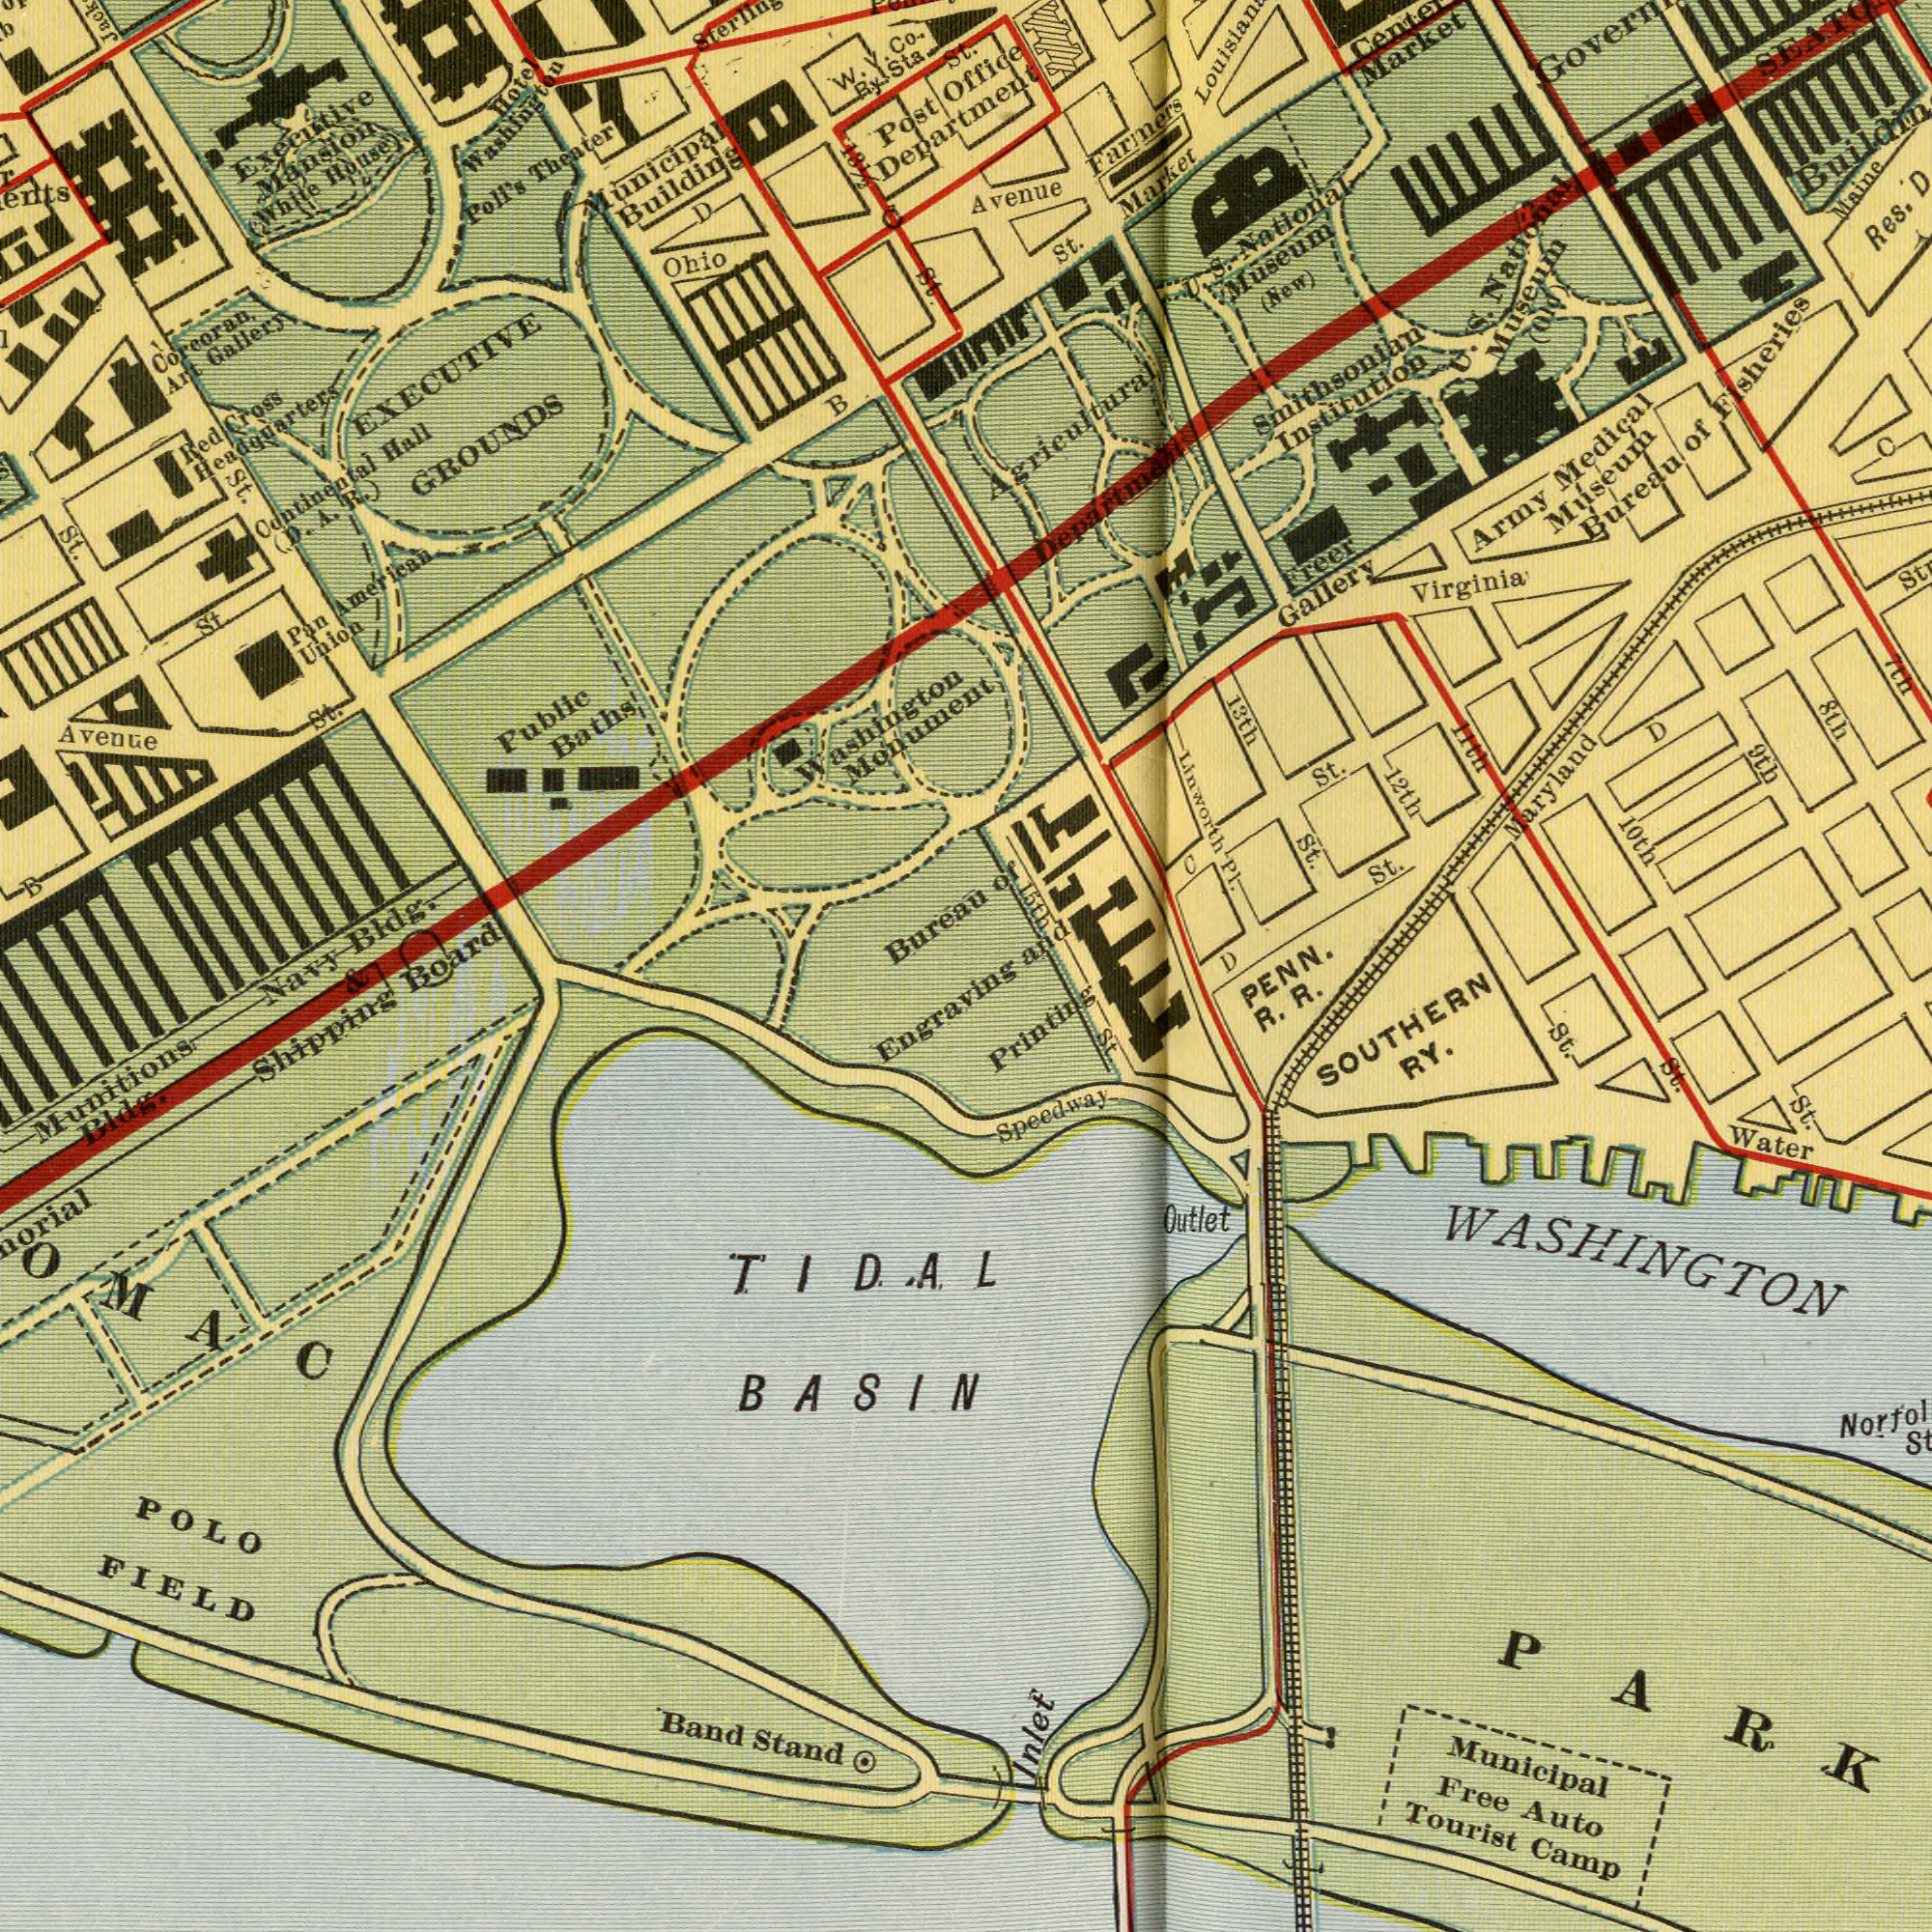What text appears in the bottom-right area of the image? Municipal Speedway Tourist Camp RY. Water Free R. Auto Outlet St. R. St. St. Inlet Printing St. WASHINGTON SOUTHERN PENN. PARK D What text appears in the top-right area of the image? Medical 10th Linworth Avenue St. Museum Institution St. St. Army 13th PI. Market 12th St. Office 8th 11th Maine Fisheries National 9th Virginia Farmers Agricultural D and D Maryland Smithsonian (New) Freer Market Department 7th Gallery Res. Museum Museum S. of S. (Old) C National of Bureau U. 15th C U. What text can you see in the bottom-left section? Board POLO Munitions TIDAL Engraving Stand Band BASIN Bldg. Shipping FIELD Navy & What text appears in the top-left area of the image? EXECUTIVE Monument Building Theater Bureau Bldg. Public Municipal Post St. Baths Ohio Mansion Gallery St. Poll's Union St. Pan Hall American St. Co. Hotel Cross Executive Red Corcoran. (White Washington GROUNDS St. House) B B Washington Avenue Art D W. (D. 13<sup>1/2</sup> C continental Headquarters Department V. Ry Sta. St. A. R.) 